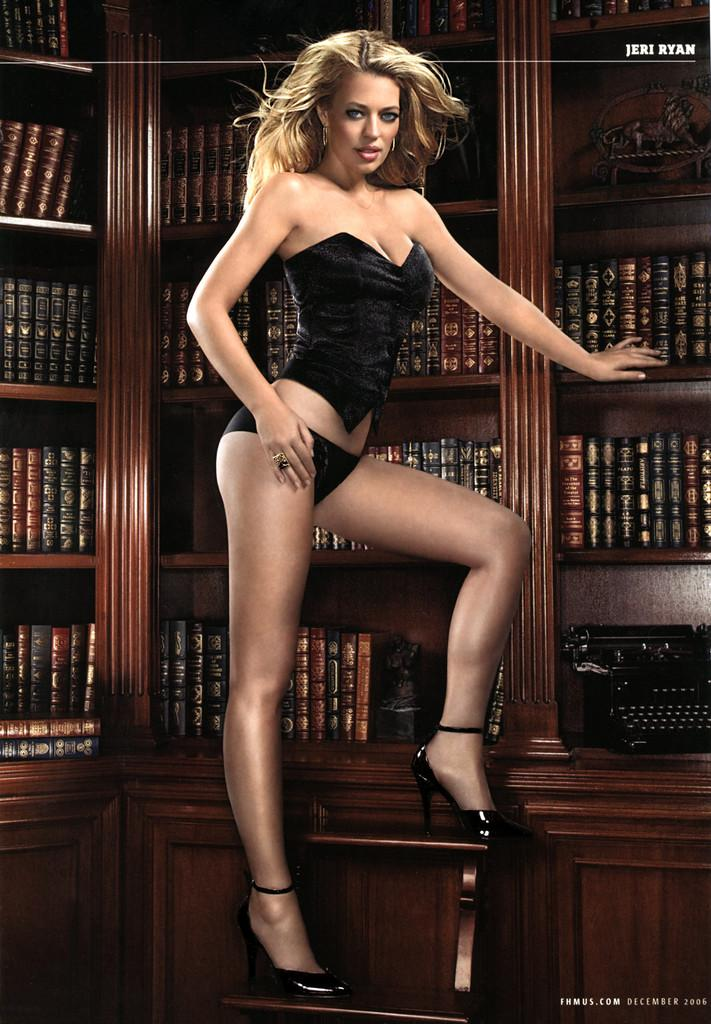Who is the main subject in the image? The main subject in the image is a person. What is the person doing in the image? The person is sitting on a chair and using a laptop. What is present on the table in front of the person? There is a cup of coffee on the table. What can be seen in the background of the image? There are no specific details about the background in the provided facts. What type of growth can be seen on the flag in the image? There is no flag present in the image, so there is no growth to observe. 